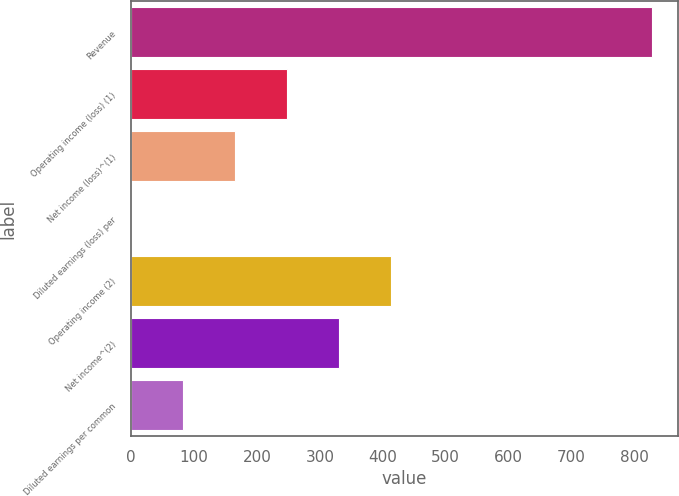Convert chart to OTSL. <chart><loc_0><loc_0><loc_500><loc_500><bar_chart><fcel>Revenue<fcel>Operating income (loss) (1)<fcel>Net income (loss)^(1)<fcel>Diluted earnings (loss) per<fcel>Operating income (2)<fcel>Net income^(2)<fcel>Diluted earnings per common<nl><fcel>827.5<fcel>248.41<fcel>165.68<fcel>0.22<fcel>413.87<fcel>331.14<fcel>82.95<nl></chart> 